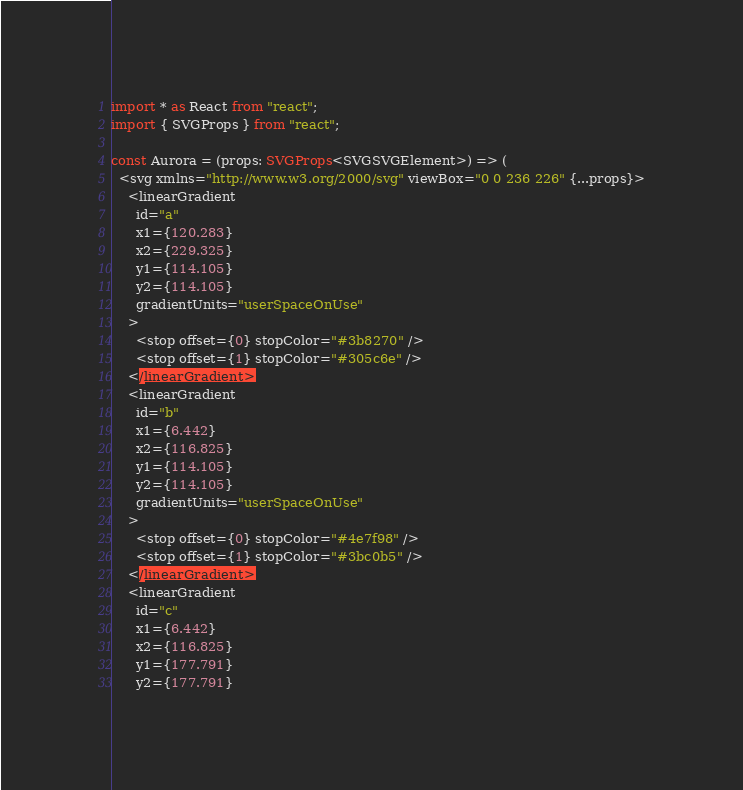Convert code to text. <code><loc_0><loc_0><loc_500><loc_500><_TypeScript_>import * as React from "react";
import { SVGProps } from "react";

const Aurora = (props: SVGProps<SVGSVGElement>) => (
  <svg xmlns="http://www.w3.org/2000/svg" viewBox="0 0 236 226" {...props}>
    <linearGradient
      id="a"
      x1={120.283}
      x2={229.325}
      y1={114.105}
      y2={114.105}
      gradientUnits="userSpaceOnUse"
    >
      <stop offset={0} stopColor="#3b8270" />
      <stop offset={1} stopColor="#305c6e" />
    </linearGradient>
    <linearGradient
      id="b"
      x1={6.442}
      x2={116.825}
      y1={114.105}
      y2={114.105}
      gradientUnits="userSpaceOnUse"
    >
      <stop offset={0} stopColor="#4e7f98" />
      <stop offset={1} stopColor="#3bc0b5" />
    </linearGradient>
    <linearGradient
      id="c"
      x1={6.442}
      x2={116.825}
      y1={177.791}
      y2={177.791}</code> 